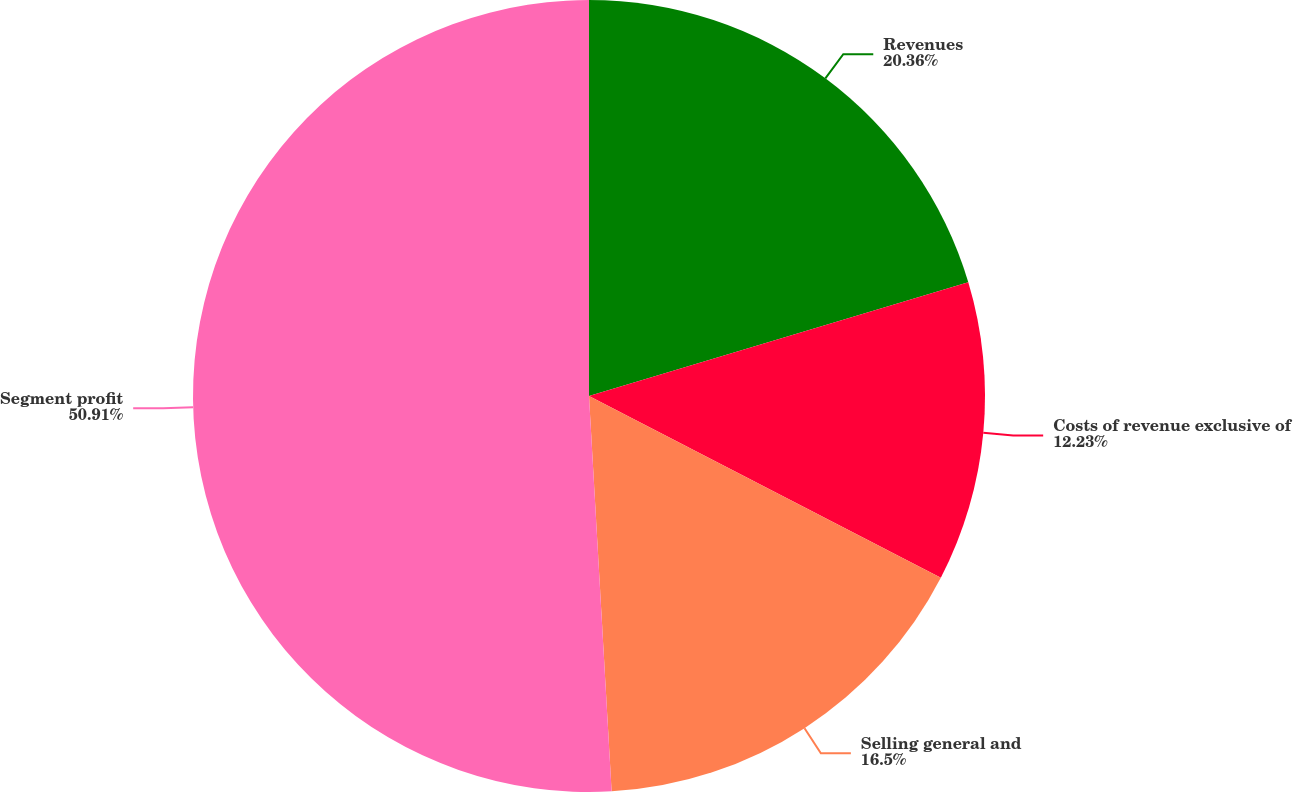Convert chart to OTSL. <chart><loc_0><loc_0><loc_500><loc_500><pie_chart><fcel>Revenues<fcel>Costs of revenue exclusive of<fcel>Selling general and<fcel>Segment profit<nl><fcel>20.36%<fcel>12.23%<fcel>16.5%<fcel>50.91%<nl></chart> 